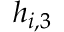Convert formula to latex. <formula><loc_0><loc_0><loc_500><loc_500>h _ { i , 3 }</formula> 